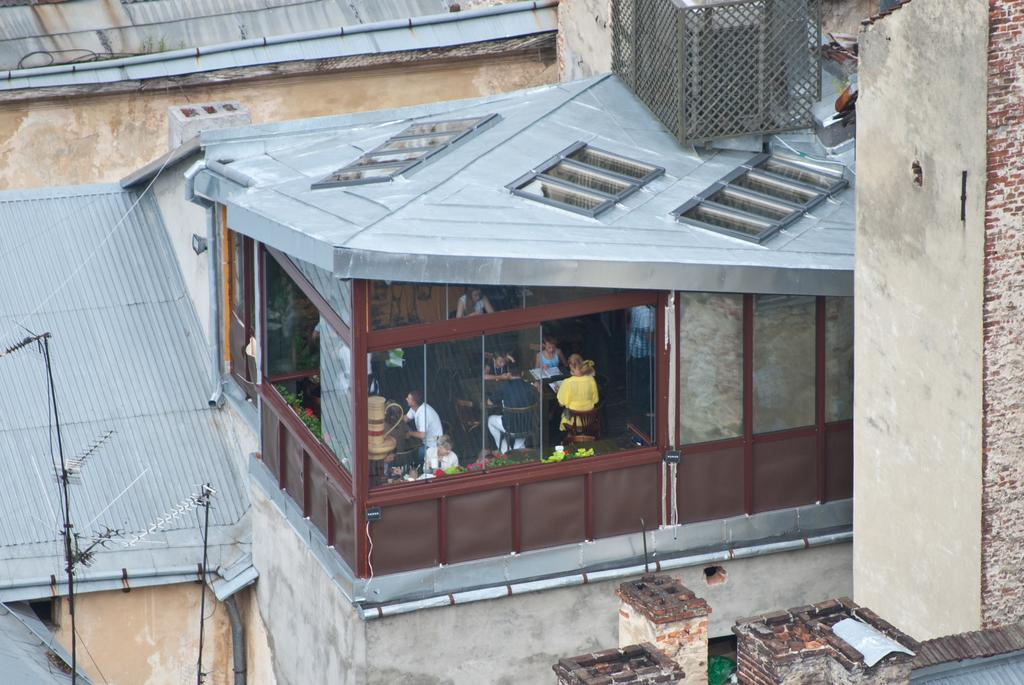What type of establishment is shown in the image? There is a shop in the image. What feature of the shop can be seen from the outside? The shop has glass windows. Can you describe the people inside the shop? There are people sitting in the shop. What is visible behind the shop? There is a wall visible in the image. What type of tax is being discussed by the shop owner and the customer in the image? There is no conversation or indication of a tax discussion in the image. 